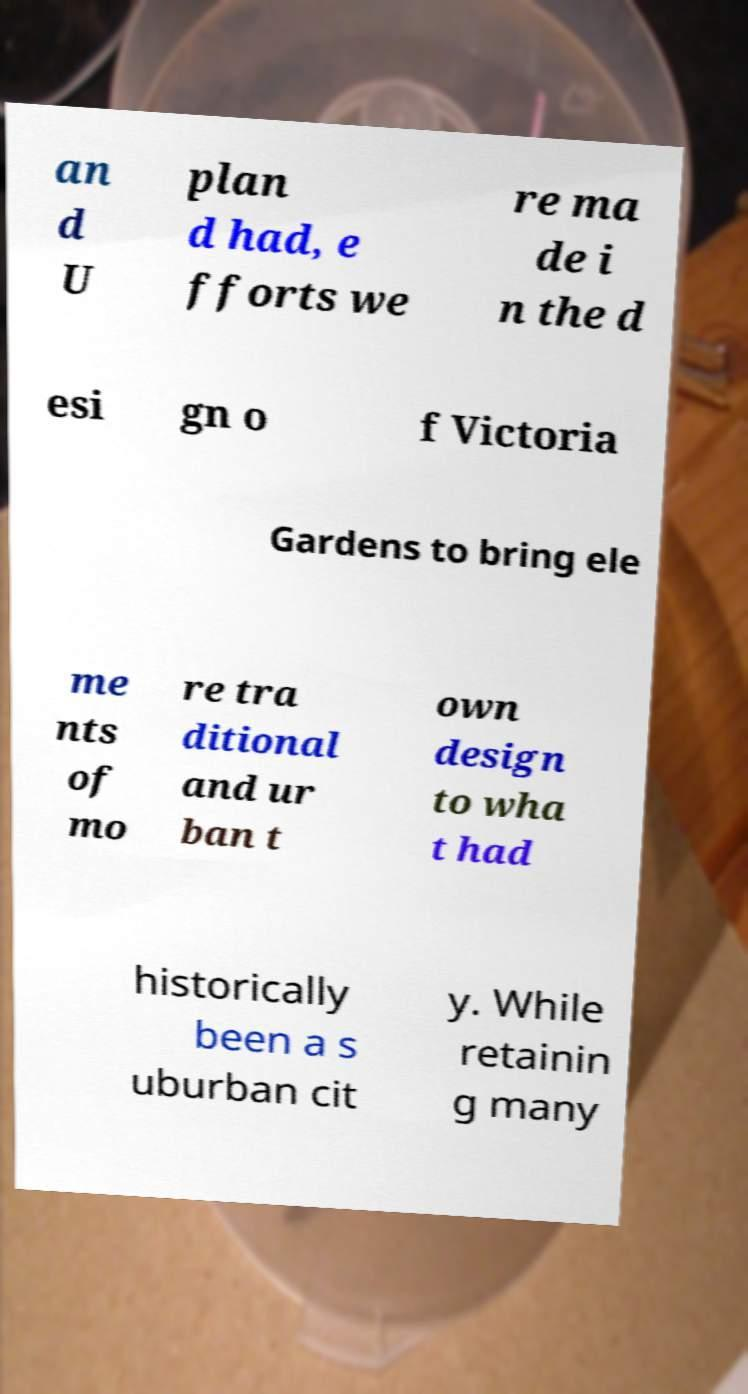I need the written content from this picture converted into text. Can you do that? an d U plan d had, e fforts we re ma de i n the d esi gn o f Victoria Gardens to bring ele me nts of mo re tra ditional and ur ban t own design to wha t had historically been a s uburban cit y. While retainin g many 